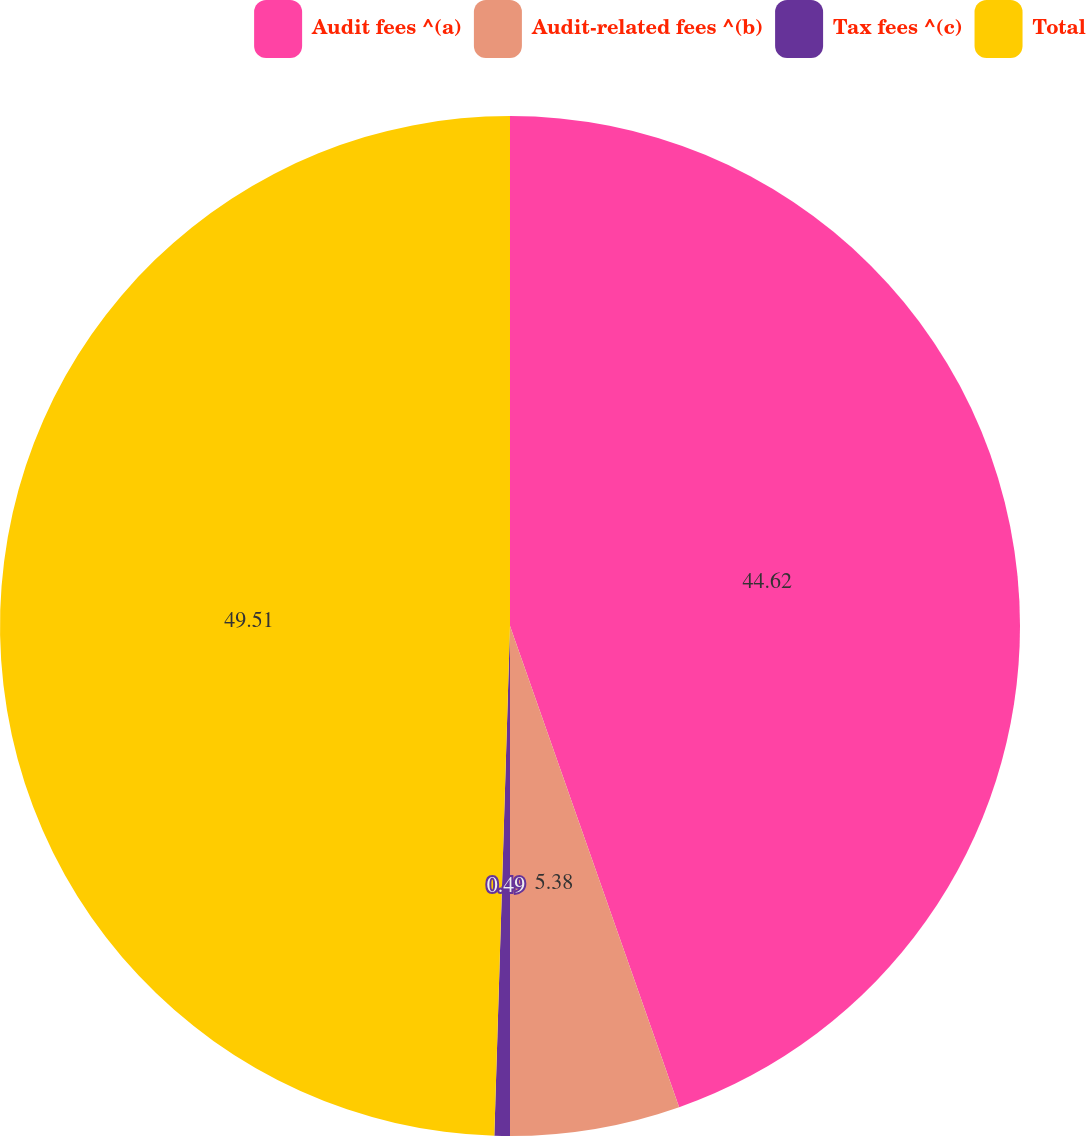<chart> <loc_0><loc_0><loc_500><loc_500><pie_chart><fcel>Audit fees ^(a)<fcel>Audit-related fees ^(b)<fcel>Tax fees ^(c)<fcel>Total<nl><fcel>44.62%<fcel>5.38%<fcel>0.49%<fcel>49.51%<nl></chart> 